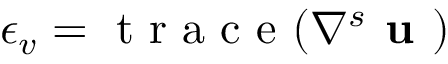<formula> <loc_0><loc_0><loc_500><loc_500>\epsilon _ { v } = t r a c e ( \nabla ^ { s } u )</formula> 